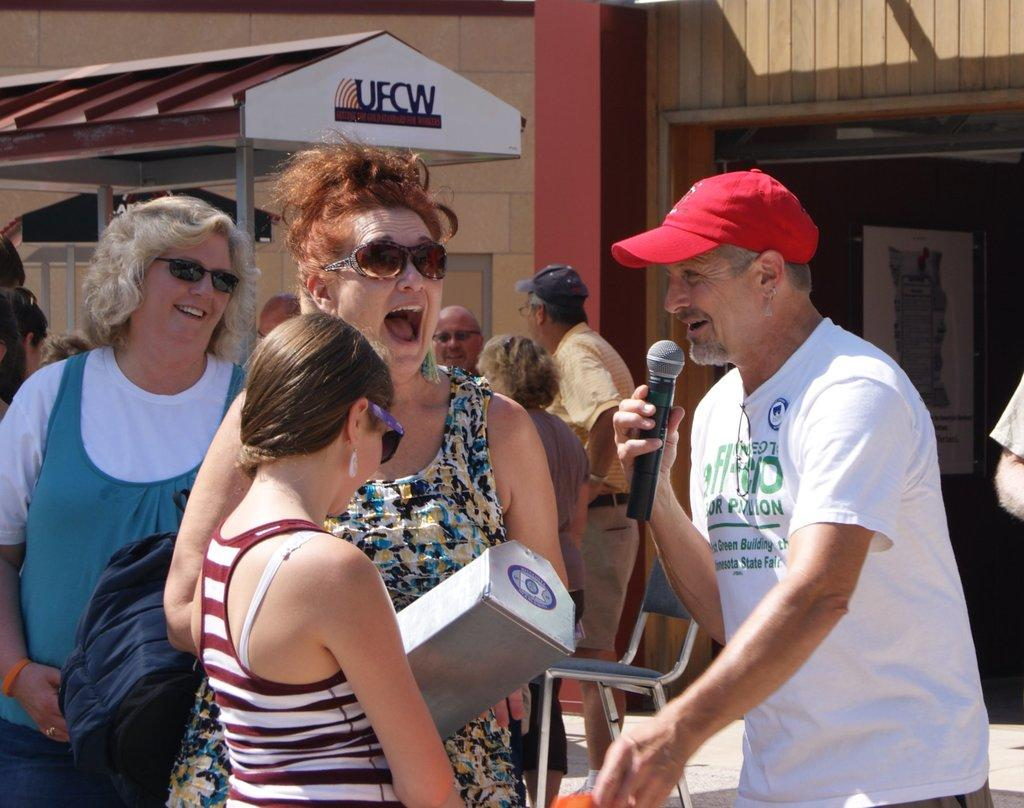How many women are present in the image? There are 3 women in the image. What is the facial expression of the women? Two of the women are smiling. What is the man in the image doing? The man is holding a microphone. Can you describe the background of the image? There are people in the background of the image. What type of wire is being used to hold the quilt in the image? There is no wire or quilt present in the image. How much milk is being poured by the man in the image? There is no milk or pouring action depicted in the image. 